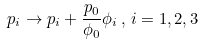Convert formula to latex. <formula><loc_0><loc_0><loc_500><loc_500>p _ { i } \rightarrow p _ { i } + \frac { p _ { 0 } } { \phi _ { 0 } } \phi _ { i } \, , \, i = 1 , 2 , 3</formula> 